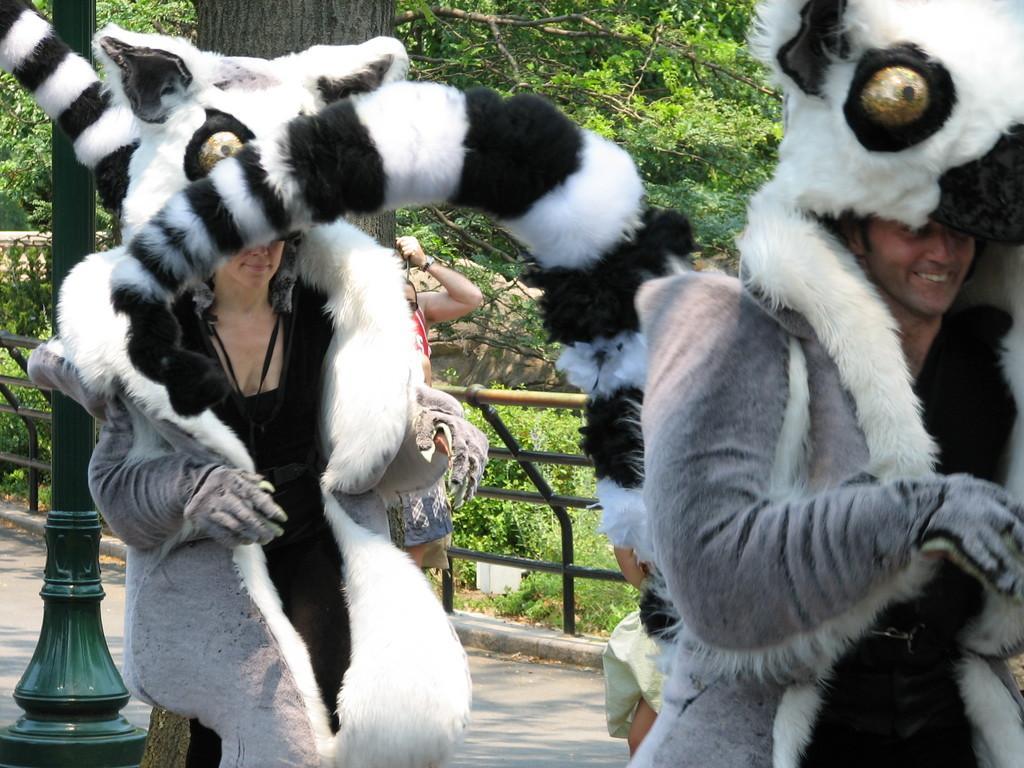How would you summarize this image in a sentence or two? In this picture we can see two persons in the costumes. Behind the two persons, there are people, railing, trees, a pole and plants. 